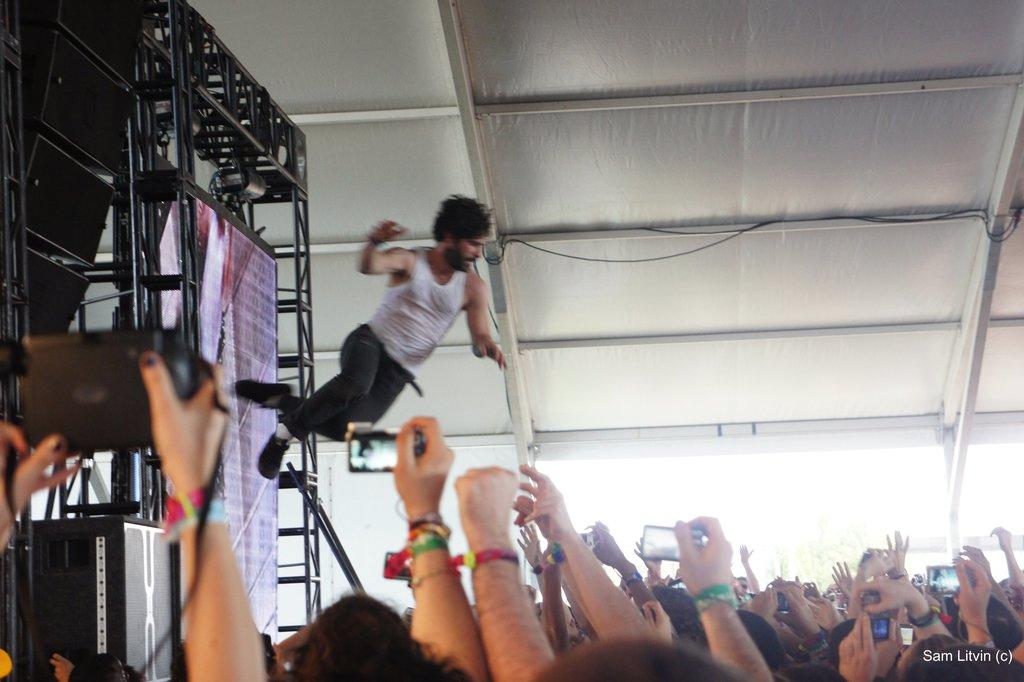What is the man in the image doing? The man is jumping in the image. What is located at the bottom of the image? There is a crowd at the bottom of the image. Who else can be seen in the image besides the man? People holding cameras are visible in the image. What can be seen in the background of the image? There are rods and pillars in the background of the image. What is the uppermost part of the structure visible in the image? There is a roof visible in the image. What type of comb is the man using to teach the crowd in the image? There is no comb or teaching activity present in the image; the man is simply jumping. 